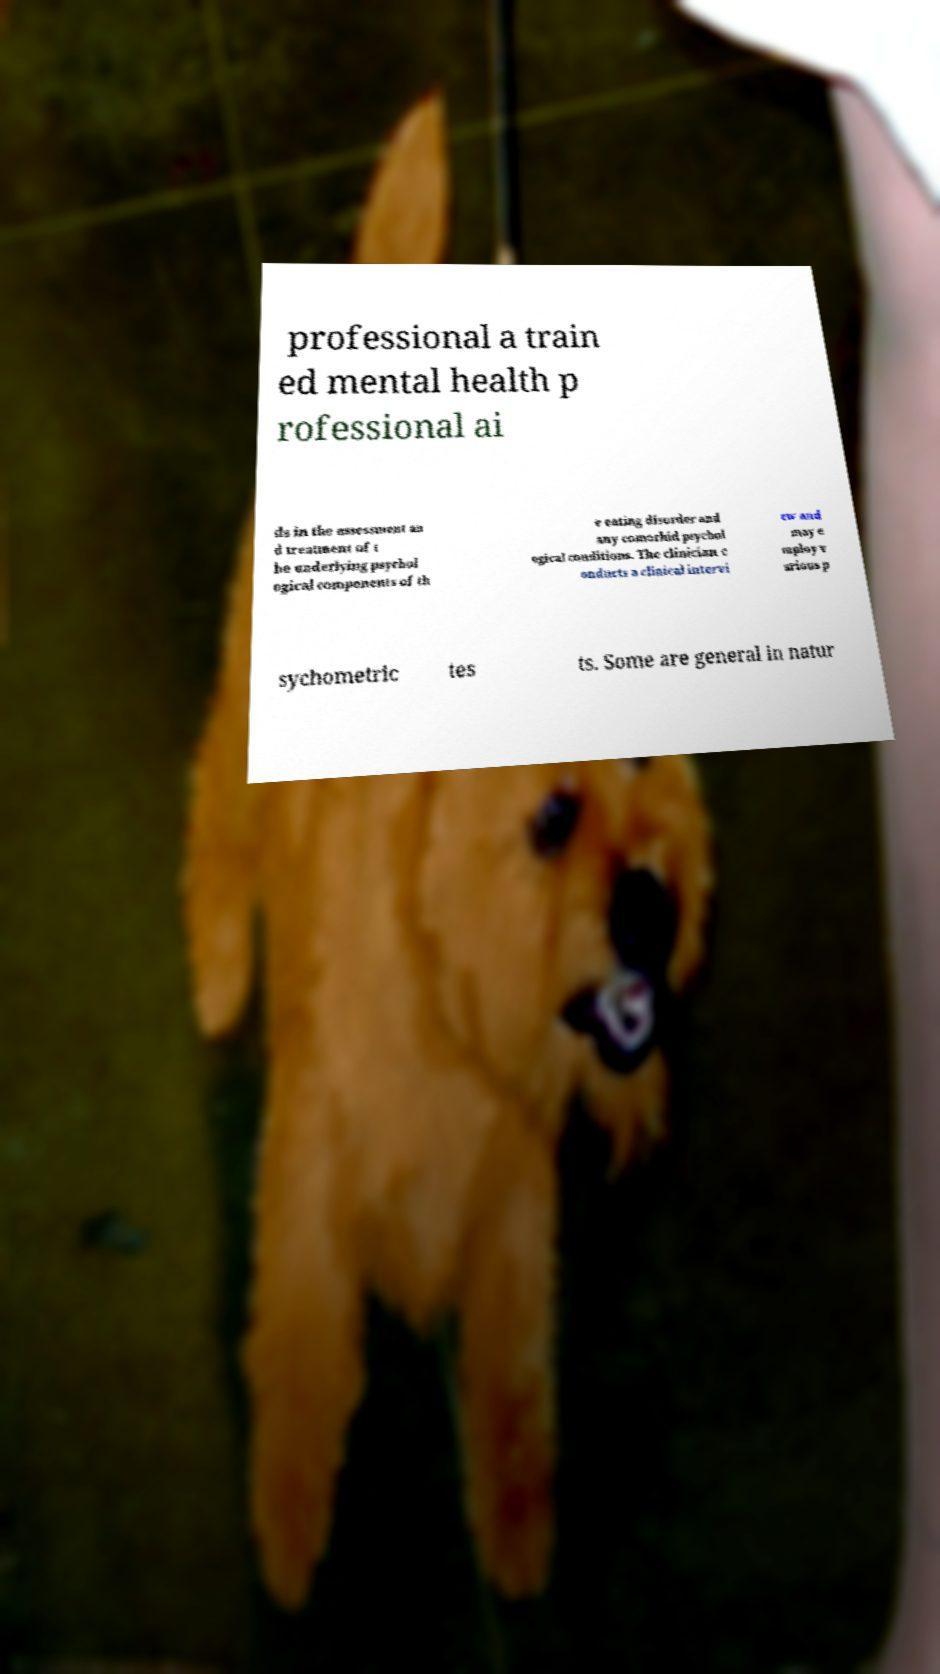Can you accurately transcribe the text from the provided image for me? professional a train ed mental health p rofessional ai ds in the assessment an d treatment of t he underlying psychol ogical components of th e eating disorder and any comorbid psychol ogical conditions. The clinician c onducts a clinical intervi ew and may e mploy v arious p sychometric tes ts. Some are general in natur 